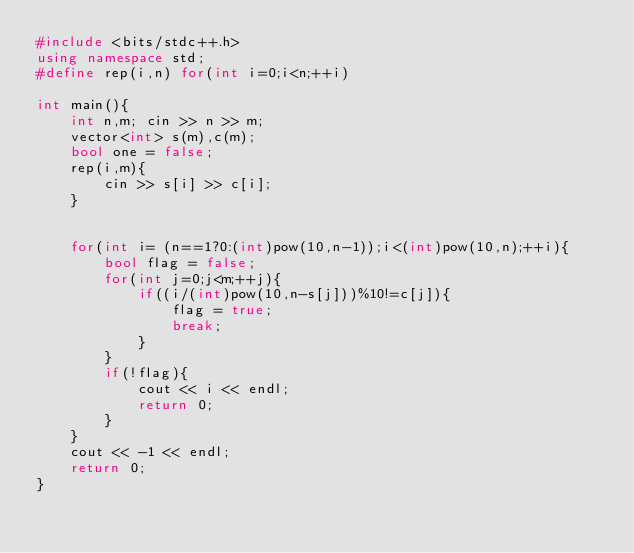Convert code to text. <code><loc_0><loc_0><loc_500><loc_500><_C++_>#include <bits/stdc++.h>
using namespace std;
#define rep(i,n) for(int i=0;i<n;++i)

int main(){
    int n,m; cin >> n >> m;
    vector<int> s(m),c(m);
    bool one = false;
    rep(i,m){
        cin >> s[i] >> c[i];
    } 


    for(int i= (n==1?0:(int)pow(10,n-1));i<(int)pow(10,n);++i){
        bool flag = false;
        for(int j=0;j<m;++j){
            if((i/(int)pow(10,n-s[j]))%10!=c[j]){
                flag = true;
                break;
            }
        }
        if(!flag){
            cout << i << endl;
            return 0;
        }
    }
    cout << -1 << endl;
    return 0;
}</code> 